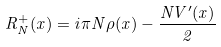Convert formula to latex. <formula><loc_0><loc_0><loc_500><loc_500>R ^ { + } _ { N } ( x ) = i \pi N \rho ( x ) - \frac { N V ^ { \prime } ( x ) } { 2 }</formula> 